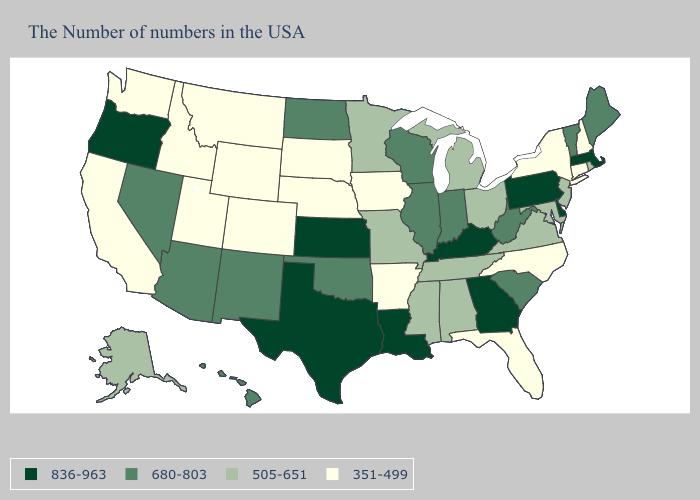Name the states that have a value in the range 680-803?
Write a very short answer. Maine, Vermont, South Carolina, West Virginia, Indiana, Wisconsin, Illinois, Oklahoma, North Dakota, New Mexico, Arizona, Nevada, Hawaii. Does Arkansas have the lowest value in the South?
Concise answer only. Yes. What is the lowest value in the USA?
Short answer required. 351-499. Is the legend a continuous bar?
Concise answer only. No. Among the states that border Texas , which have the lowest value?
Be succinct. Arkansas. What is the value of Louisiana?
Quick response, please. 836-963. What is the value of New Mexico?
Answer briefly. 680-803. What is the value of Connecticut?
Concise answer only. 351-499. What is the value of New York?
Quick response, please. 351-499. Among the states that border Illinois , which have the lowest value?
Short answer required. Iowa. Does the map have missing data?
Write a very short answer. No. What is the value of Ohio?
Concise answer only. 505-651. What is the value of Hawaii?
Be succinct. 680-803. What is the highest value in the USA?
Be succinct. 836-963. Does New York have the lowest value in the Northeast?
Short answer required. Yes. 